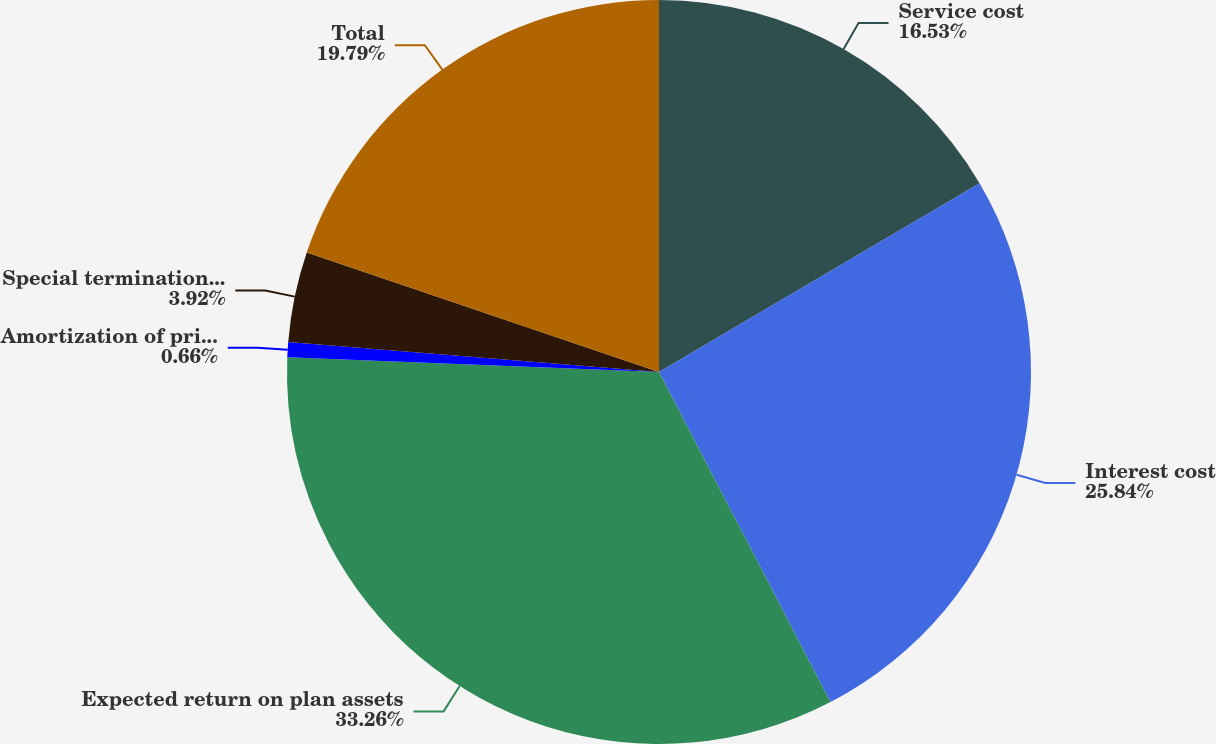<chart> <loc_0><loc_0><loc_500><loc_500><pie_chart><fcel>Service cost<fcel>Interest cost<fcel>Expected return on plan assets<fcel>Amortization of prior service<fcel>Special termination benefits<fcel>Total<nl><fcel>16.53%<fcel>25.84%<fcel>33.25%<fcel>0.66%<fcel>3.92%<fcel>19.79%<nl></chart> 